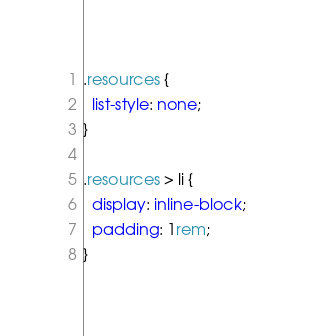<code> <loc_0><loc_0><loc_500><loc_500><_CSS_>.resources {
  list-style: none;
}

.resources > li {
  display: inline-block;
  padding: 1rem;
}
</code> 